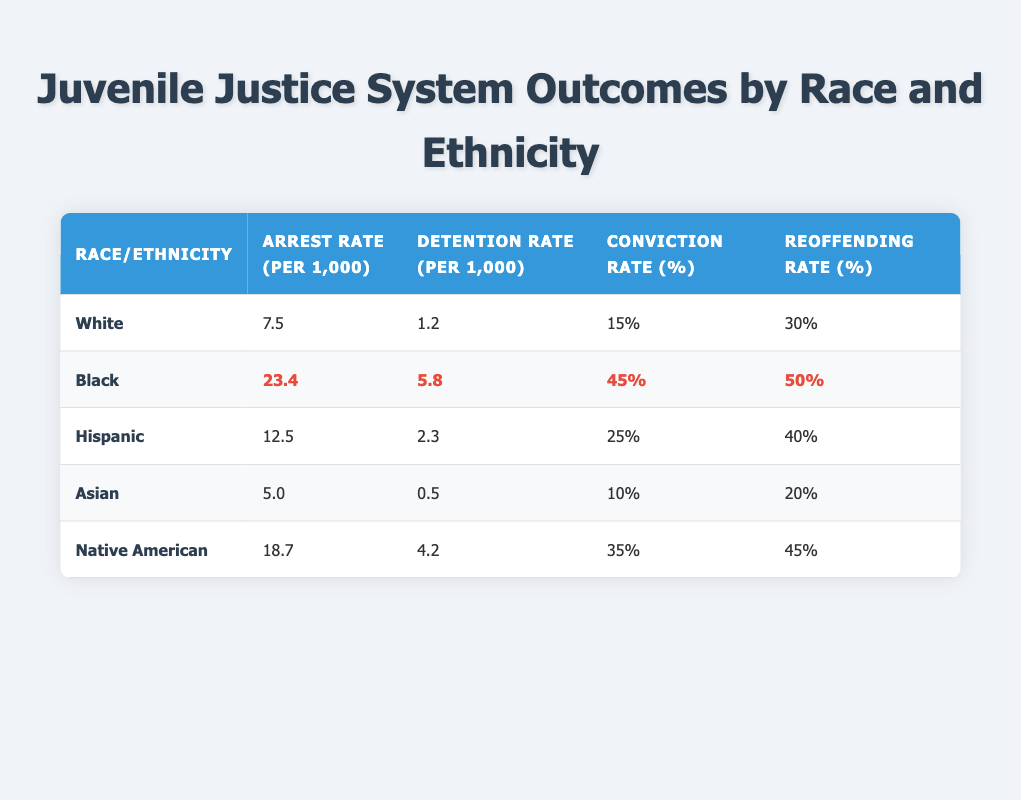What is the arrest rate for the Black youth? The arrest rate for Black youth can be directly found in the table under the "Arrest Rate (per 1,000)" column, next to the "Black" row. The value is 23.4.
Answer: 23.4 What is the detention rate for Hispanic youth? Looking at the "Detention Rate (per 1,000)" column, the value in the row for Hispanic youth is 2.3.
Answer: 2.3 Among the races listed, which has the highest conviction rate? By reviewing the "Conviction Rate (%)" column, the Black youth have the highest conviction rate at 45%.
Answer: Black What is the average reoffending rate for all the racial/ethnic groups combined? To calculate the average, we sum the reoffending rates: (30 + 50 + 40 + 20 + 45) = 225. Then, we divide by the number of groups (5): 225/5 = 45.
Answer: 45 Is the reoffending rate for Asian youth lower than that for White youth? The reoffending rate for Asian youth is 20%, and for White youth, it is 30%. Since 20% is less than 30%, the statement is true.
Answer: Yes What is the difference between the arrest rates of Black and White youth? The arrest rate for Black youth is 23.4, and for White youth, it is 7.5. The difference can be calculated as: 23.4 - 7.5 = 15.9.
Answer: 15.9 Do Native American youth have a higher detention rate than Asian youth? The detention rate for Native American youth is 4.2, while for Asian youth, it is 0.5. Since 4.2 is greater than 0.5, the statement is true.
Answer: Yes Which racial or ethnic group has the lowest arrest rate? By inspecting the "Arrest Rate (per 1,000)" column, we see that Asian youth have the lowest rate at 5.0.
Answer: Asian What is the total conviction rate when combining the rates of Hispanic and Native American youth? The conviction rate for Hispanic youth is 25%, and for Native American youth, it is 35%. To find the total, we simply add the two rates: 25 + 35 = 60.
Answer: 60 